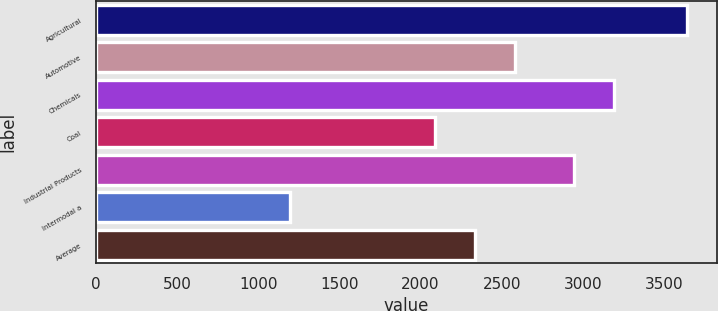<chart> <loc_0><loc_0><loc_500><loc_500><bar_chart><fcel>Agricultural<fcel>Automotive<fcel>Chemicals<fcel>Coal<fcel>Industrial Products<fcel>Intermodal a<fcel>Average<nl><fcel>3644<fcel>2582<fcel>3192<fcel>2092<fcel>2947<fcel>1194<fcel>2337<nl></chart> 